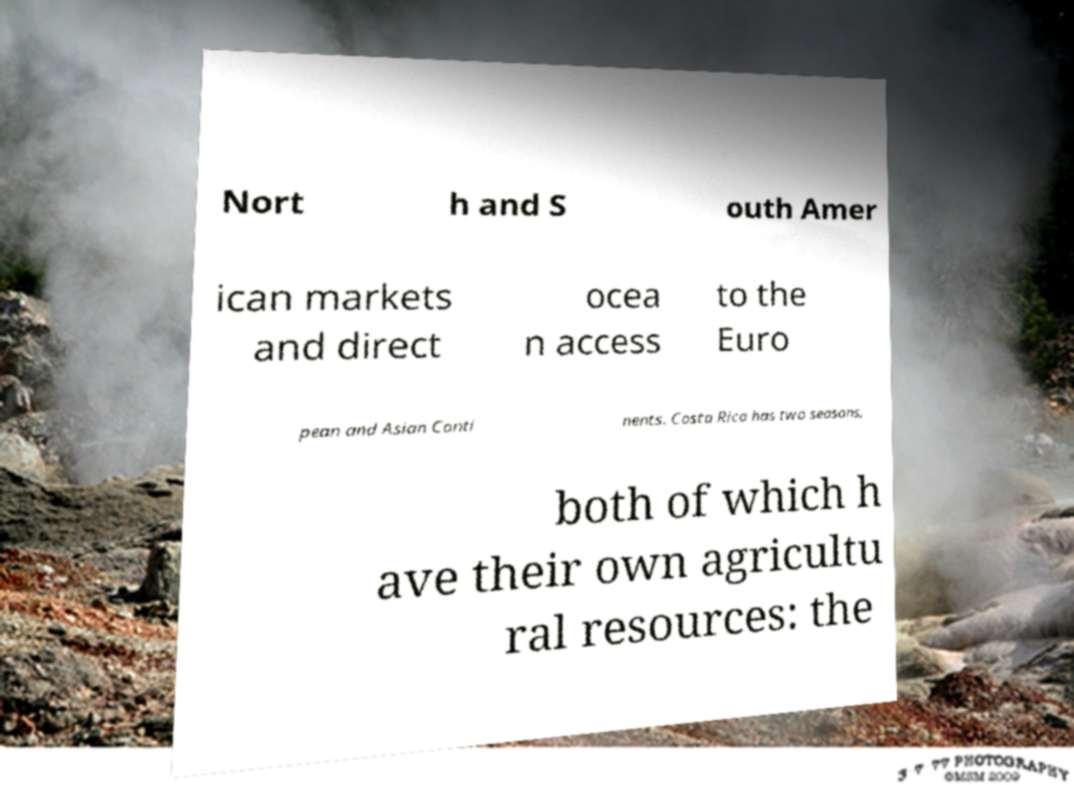Can you read and provide the text displayed in the image?This photo seems to have some interesting text. Can you extract and type it out for me? Nort h and S outh Amer ican markets and direct ocea n access to the Euro pean and Asian Conti nents. Costa Rica has two seasons, both of which h ave their own agricultu ral resources: the 